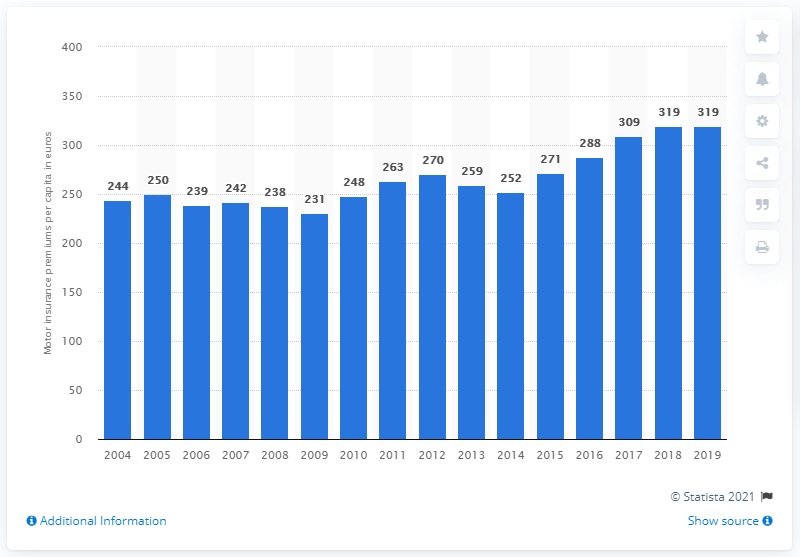Besides the increase in 2017, what other specific changes or patterns can you identify in this data? Apart from the sharp increase in 2017, you can observe a few other patterns in the data. There's a considerable rise between 2004 and 2009, followed by smaller variations with a minimal decrease around 2012 and another peak in 2015. Post-2017, a plateau is observed with the premium remaining consistent. 